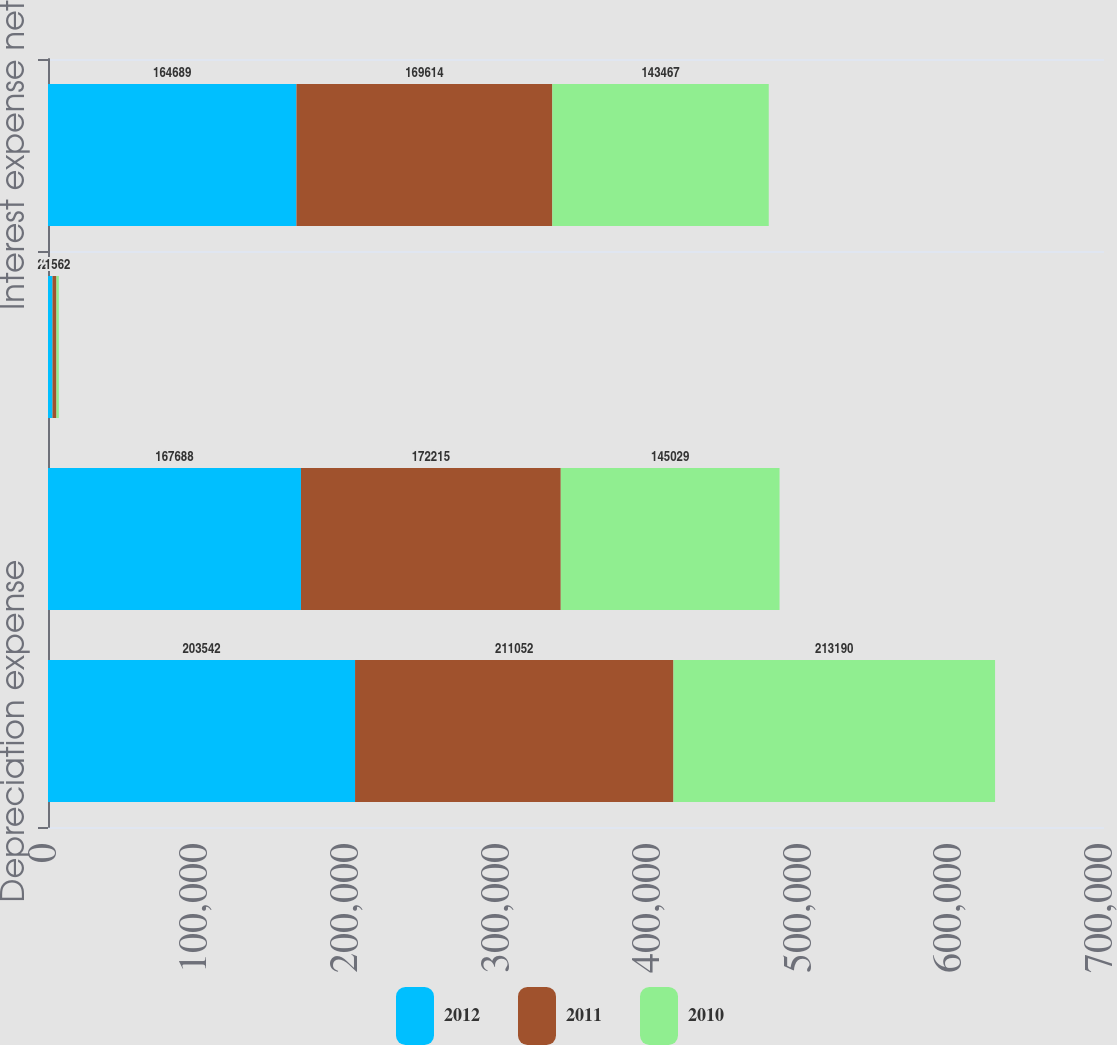Convert chart. <chart><loc_0><loc_0><loc_500><loc_500><stacked_bar_chart><ecel><fcel>Depreciation expense<fcel>Interest expense<fcel>Interest income<fcel>Interest expense net<nl><fcel>2012<fcel>203542<fcel>167688<fcel>2999<fcel>164689<nl><fcel>2011<fcel>211052<fcel>172215<fcel>2601<fcel>169614<nl><fcel>2010<fcel>213190<fcel>145029<fcel>1562<fcel>143467<nl></chart> 